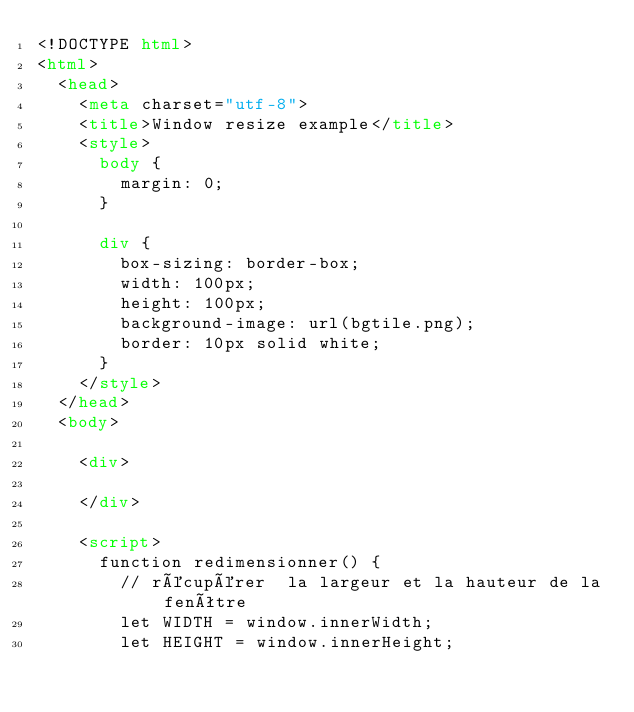<code> <loc_0><loc_0><loc_500><loc_500><_HTML_><!DOCTYPE html>
<html>
  <head>
    <meta charset="utf-8">
    <title>Window resize example</title>
    <style>
      body {
        margin: 0;
      }

      div {
        box-sizing: border-box;
        width: 100px;
        height: 100px;
        background-image: url(bgtile.png);
        border: 10px solid white;
      }
    </style>
  </head>
  <body>

    <div>

    </div>

    <script>
      function redimensionner() {
        // récupérer  la largeur et la hauteur de la fenêtre
        let WIDTH = window.innerWidth;
        let HEIGHT = window.innerHeight;</code> 